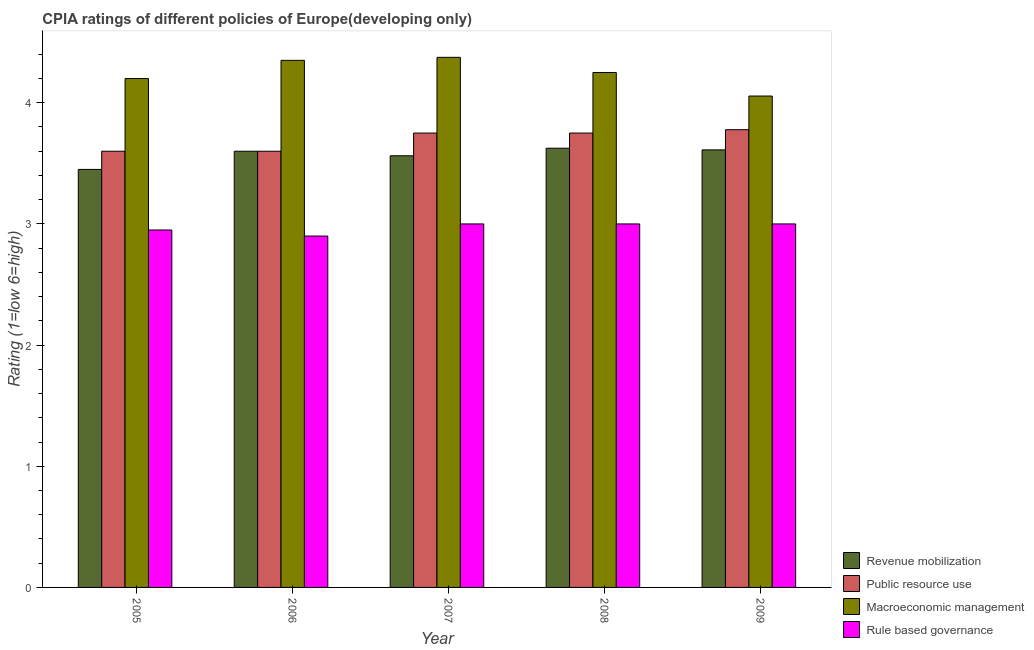How many different coloured bars are there?
Give a very brief answer. 4. Are the number of bars on each tick of the X-axis equal?
Offer a very short reply. Yes. How many bars are there on the 1st tick from the left?
Keep it short and to the point. 4. What is the cpia rating of revenue mobilization in 2008?
Provide a short and direct response. 3.62. Across all years, what is the maximum cpia rating of rule based governance?
Your response must be concise. 3. Across all years, what is the minimum cpia rating of rule based governance?
Make the answer very short. 2.9. In which year was the cpia rating of public resource use minimum?
Provide a succinct answer. 2005. What is the total cpia rating of rule based governance in the graph?
Give a very brief answer. 14.85. What is the difference between the cpia rating of macroeconomic management in 2006 and that in 2007?
Provide a short and direct response. -0.03. What is the difference between the cpia rating of public resource use in 2008 and the cpia rating of rule based governance in 2007?
Provide a short and direct response. 0. What is the average cpia rating of revenue mobilization per year?
Provide a succinct answer. 3.57. What is the ratio of the cpia rating of macroeconomic management in 2006 to that in 2007?
Your answer should be compact. 0.99. Is the difference between the cpia rating of macroeconomic management in 2005 and 2007 greater than the difference between the cpia rating of rule based governance in 2005 and 2007?
Ensure brevity in your answer.  No. What is the difference between the highest and the second highest cpia rating of macroeconomic management?
Offer a terse response. 0.03. What is the difference between the highest and the lowest cpia rating of rule based governance?
Make the answer very short. 0.1. In how many years, is the cpia rating of rule based governance greater than the average cpia rating of rule based governance taken over all years?
Offer a terse response. 3. Is it the case that in every year, the sum of the cpia rating of revenue mobilization and cpia rating of rule based governance is greater than the sum of cpia rating of public resource use and cpia rating of macroeconomic management?
Provide a succinct answer. No. What does the 1st bar from the left in 2006 represents?
Keep it short and to the point. Revenue mobilization. What does the 4th bar from the right in 2007 represents?
Your answer should be very brief. Revenue mobilization. Is it the case that in every year, the sum of the cpia rating of revenue mobilization and cpia rating of public resource use is greater than the cpia rating of macroeconomic management?
Offer a very short reply. Yes. How many bars are there?
Your response must be concise. 20. Are all the bars in the graph horizontal?
Make the answer very short. No. How many years are there in the graph?
Give a very brief answer. 5. What is the difference between two consecutive major ticks on the Y-axis?
Give a very brief answer. 1. Does the graph contain any zero values?
Your answer should be compact. No. Does the graph contain grids?
Make the answer very short. No. Where does the legend appear in the graph?
Offer a terse response. Bottom right. How are the legend labels stacked?
Offer a very short reply. Vertical. What is the title of the graph?
Your response must be concise. CPIA ratings of different policies of Europe(developing only). What is the label or title of the Y-axis?
Make the answer very short. Rating (1=low 6=high). What is the Rating (1=low 6=high) of Revenue mobilization in 2005?
Provide a short and direct response. 3.45. What is the Rating (1=low 6=high) in Public resource use in 2005?
Your answer should be compact. 3.6. What is the Rating (1=low 6=high) of Macroeconomic management in 2005?
Make the answer very short. 4.2. What is the Rating (1=low 6=high) of Rule based governance in 2005?
Your answer should be compact. 2.95. What is the Rating (1=low 6=high) in Public resource use in 2006?
Make the answer very short. 3.6. What is the Rating (1=low 6=high) of Macroeconomic management in 2006?
Give a very brief answer. 4.35. What is the Rating (1=low 6=high) in Revenue mobilization in 2007?
Provide a succinct answer. 3.56. What is the Rating (1=low 6=high) of Public resource use in 2007?
Give a very brief answer. 3.75. What is the Rating (1=low 6=high) of Macroeconomic management in 2007?
Provide a short and direct response. 4.38. What is the Rating (1=low 6=high) of Revenue mobilization in 2008?
Provide a succinct answer. 3.62. What is the Rating (1=low 6=high) in Public resource use in 2008?
Offer a very short reply. 3.75. What is the Rating (1=low 6=high) in Macroeconomic management in 2008?
Make the answer very short. 4.25. What is the Rating (1=low 6=high) in Revenue mobilization in 2009?
Your answer should be compact. 3.61. What is the Rating (1=low 6=high) of Public resource use in 2009?
Provide a succinct answer. 3.78. What is the Rating (1=low 6=high) of Macroeconomic management in 2009?
Give a very brief answer. 4.06. Across all years, what is the maximum Rating (1=low 6=high) in Revenue mobilization?
Provide a succinct answer. 3.62. Across all years, what is the maximum Rating (1=low 6=high) in Public resource use?
Ensure brevity in your answer.  3.78. Across all years, what is the maximum Rating (1=low 6=high) of Macroeconomic management?
Offer a terse response. 4.38. Across all years, what is the maximum Rating (1=low 6=high) in Rule based governance?
Ensure brevity in your answer.  3. Across all years, what is the minimum Rating (1=low 6=high) in Revenue mobilization?
Provide a short and direct response. 3.45. Across all years, what is the minimum Rating (1=low 6=high) of Public resource use?
Provide a succinct answer. 3.6. Across all years, what is the minimum Rating (1=low 6=high) in Macroeconomic management?
Your answer should be compact. 4.06. Across all years, what is the minimum Rating (1=low 6=high) in Rule based governance?
Make the answer very short. 2.9. What is the total Rating (1=low 6=high) of Revenue mobilization in the graph?
Offer a terse response. 17.85. What is the total Rating (1=low 6=high) of Public resource use in the graph?
Provide a short and direct response. 18.48. What is the total Rating (1=low 6=high) of Macroeconomic management in the graph?
Offer a terse response. 21.23. What is the total Rating (1=low 6=high) of Rule based governance in the graph?
Your answer should be compact. 14.85. What is the difference between the Rating (1=low 6=high) in Rule based governance in 2005 and that in 2006?
Offer a very short reply. 0.05. What is the difference between the Rating (1=low 6=high) in Revenue mobilization in 2005 and that in 2007?
Keep it short and to the point. -0.11. What is the difference between the Rating (1=low 6=high) in Macroeconomic management in 2005 and that in 2007?
Make the answer very short. -0.17. What is the difference between the Rating (1=low 6=high) in Rule based governance in 2005 and that in 2007?
Ensure brevity in your answer.  -0.05. What is the difference between the Rating (1=low 6=high) in Revenue mobilization in 2005 and that in 2008?
Provide a succinct answer. -0.17. What is the difference between the Rating (1=low 6=high) of Public resource use in 2005 and that in 2008?
Offer a terse response. -0.15. What is the difference between the Rating (1=low 6=high) of Macroeconomic management in 2005 and that in 2008?
Your answer should be compact. -0.05. What is the difference between the Rating (1=low 6=high) in Rule based governance in 2005 and that in 2008?
Your answer should be very brief. -0.05. What is the difference between the Rating (1=low 6=high) in Revenue mobilization in 2005 and that in 2009?
Your response must be concise. -0.16. What is the difference between the Rating (1=low 6=high) in Public resource use in 2005 and that in 2009?
Provide a succinct answer. -0.18. What is the difference between the Rating (1=low 6=high) of Macroeconomic management in 2005 and that in 2009?
Your answer should be compact. 0.14. What is the difference between the Rating (1=low 6=high) in Revenue mobilization in 2006 and that in 2007?
Provide a short and direct response. 0.04. What is the difference between the Rating (1=low 6=high) in Macroeconomic management in 2006 and that in 2007?
Keep it short and to the point. -0.03. What is the difference between the Rating (1=low 6=high) of Revenue mobilization in 2006 and that in 2008?
Offer a terse response. -0.03. What is the difference between the Rating (1=low 6=high) of Public resource use in 2006 and that in 2008?
Make the answer very short. -0.15. What is the difference between the Rating (1=low 6=high) of Macroeconomic management in 2006 and that in 2008?
Offer a terse response. 0.1. What is the difference between the Rating (1=low 6=high) in Rule based governance in 2006 and that in 2008?
Offer a terse response. -0.1. What is the difference between the Rating (1=low 6=high) of Revenue mobilization in 2006 and that in 2009?
Ensure brevity in your answer.  -0.01. What is the difference between the Rating (1=low 6=high) in Public resource use in 2006 and that in 2009?
Keep it short and to the point. -0.18. What is the difference between the Rating (1=low 6=high) of Macroeconomic management in 2006 and that in 2009?
Provide a short and direct response. 0.29. What is the difference between the Rating (1=low 6=high) in Rule based governance in 2006 and that in 2009?
Your answer should be compact. -0.1. What is the difference between the Rating (1=low 6=high) in Revenue mobilization in 2007 and that in 2008?
Make the answer very short. -0.06. What is the difference between the Rating (1=low 6=high) of Public resource use in 2007 and that in 2008?
Your answer should be very brief. 0. What is the difference between the Rating (1=low 6=high) of Rule based governance in 2007 and that in 2008?
Provide a short and direct response. 0. What is the difference between the Rating (1=low 6=high) of Revenue mobilization in 2007 and that in 2009?
Provide a short and direct response. -0.05. What is the difference between the Rating (1=low 6=high) of Public resource use in 2007 and that in 2009?
Your answer should be compact. -0.03. What is the difference between the Rating (1=low 6=high) of Macroeconomic management in 2007 and that in 2009?
Provide a succinct answer. 0.32. What is the difference between the Rating (1=low 6=high) in Rule based governance in 2007 and that in 2009?
Your answer should be very brief. 0. What is the difference between the Rating (1=low 6=high) in Revenue mobilization in 2008 and that in 2009?
Provide a succinct answer. 0.01. What is the difference between the Rating (1=low 6=high) in Public resource use in 2008 and that in 2009?
Keep it short and to the point. -0.03. What is the difference between the Rating (1=low 6=high) of Macroeconomic management in 2008 and that in 2009?
Ensure brevity in your answer.  0.19. What is the difference between the Rating (1=low 6=high) of Rule based governance in 2008 and that in 2009?
Make the answer very short. 0. What is the difference between the Rating (1=low 6=high) of Revenue mobilization in 2005 and the Rating (1=low 6=high) of Public resource use in 2006?
Keep it short and to the point. -0.15. What is the difference between the Rating (1=low 6=high) in Revenue mobilization in 2005 and the Rating (1=low 6=high) in Rule based governance in 2006?
Give a very brief answer. 0.55. What is the difference between the Rating (1=low 6=high) in Public resource use in 2005 and the Rating (1=low 6=high) in Macroeconomic management in 2006?
Provide a short and direct response. -0.75. What is the difference between the Rating (1=low 6=high) in Macroeconomic management in 2005 and the Rating (1=low 6=high) in Rule based governance in 2006?
Offer a very short reply. 1.3. What is the difference between the Rating (1=low 6=high) in Revenue mobilization in 2005 and the Rating (1=low 6=high) in Public resource use in 2007?
Your answer should be very brief. -0.3. What is the difference between the Rating (1=low 6=high) in Revenue mobilization in 2005 and the Rating (1=low 6=high) in Macroeconomic management in 2007?
Offer a very short reply. -0.93. What is the difference between the Rating (1=low 6=high) in Revenue mobilization in 2005 and the Rating (1=low 6=high) in Rule based governance in 2007?
Your response must be concise. 0.45. What is the difference between the Rating (1=low 6=high) in Public resource use in 2005 and the Rating (1=low 6=high) in Macroeconomic management in 2007?
Keep it short and to the point. -0.78. What is the difference between the Rating (1=low 6=high) in Revenue mobilization in 2005 and the Rating (1=low 6=high) in Public resource use in 2008?
Give a very brief answer. -0.3. What is the difference between the Rating (1=low 6=high) of Revenue mobilization in 2005 and the Rating (1=low 6=high) of Macroeconomic management in 2008?
Keep it short and to the point. -0.8. What is the difference between the Rating (1=low 6=high) in Revenue mobilization in 2005 and the Rating (1=low 6=high) in Rule based governance in 2008?
Offer a very short reply. 0.45. What is the difference between the Rating (1=low 6=high) of Public resource use in 2005 and the Rating (1=low 6=high) of Macroeconomic management in 2008?
Keep it short and to the point. -0.65. What is the difference between the Rating (1=low 6=high) of Revenue mobilization in 2005 and the Rating (1=low 6=high) of Public resource use in 2009?
Provide a short and direct response. -0.33. What is the difference between the Rating (1=low 6=high) in Revenue mobilization in 2005 and the Rating (1=low 6=high) in Macroeconomic management in 2009?
Offer a very short reply. -0.61. What is the difference between the Rating (1=low 6=high) of Revenue mobilization in 2005 and the Rating (1=low 6=high) of Rule based governance in 2009?
Your response must be concise. 0.45. What is the difference between the Rating (1=low 6=high) in Public resource use in 2005 and the Rating (1=low 6=high) in Macroeconomic management in 2009?
Your response must be concise. -0.46. What is the difference between the Rating (1=low 6=high) of Public resource use in 2005 and the Rating (1=low 6=high) of Rule based governance in 2009?
Provide a short and direct response. 0.6. What is the difference between the Rating (1=low 6=high) of Macroeconomic management in 2005 and the Rating (1=low 6=high) of Rule based governance in 2009?
Keep it short and to the point. 1.2. What is the difference between the Rating (1=low 6=high) in Revenue mobilization in 2006 and the Rating (1=low 6=high) in Macroeconomic management in 2007?
Provide a short and direct response. -0.78. What is the difference between the Rating (1=low 6=high) in Public resource use in 2006 and the Rating (1=low 6=high) in Macroeconomic management in 2007?
Provide a succinct answer. -0.78. What is the difference between the Rating (1=low 6=high) in Public resource use in 2006 and the Rating (1=low 6=high) in Rule based governance in 2007?
Offer a terse response. 0.6. What is the difference between the Rating (1=low 6=high) in Macroeconomic management in 2006 and the Rating (1=low 6=high) in Rule based governance in 2007?
Provide a succinct answer. 1.35. What is the difference between the Rating (1=low 6=high) of Revenue mobilization in 2006 and the Rating (1=low 6=high) of Macroeconomic management in 2008?
Keep it short and to the point. -0.65. What is the difference between the Rating (1=low 6=high) in Public resource use in 2006 and the Rating (1=low 6=high) in Macroeconomic management in 2008?
Make the answer very short. -0.65. What is the difference between the Rating (1=low 6=high) of Public resource use in 2006 and the Rating (1=low 6=high) of Rule based governance in 2008?
Provide a short and direct response. 0.6. What is the difference between the Rating (1=low 6=high) in Macroeconomic management in 2006 and the Rating (1=low 6=high) in Rule based governance in 2008?
Keep it short and to the point. 1.35. What is the difference between the Rating (1=low 6=high) in Revenue mobilization in 2006 and the Rating (1=low 6=high) in Public resource use in 2009?
Offer a very short reply. -0.18. What is the difference between the Rating (1=low 6=high) of Revenue mobilization in 2006 and the Rating (1=low 6=high) of Macroeconomic management in 2009?
Offer a terse response. -0.46. What is the difference between the Rating (1=low 6=high) in Revenue mobilization in 2006 and the Rating (1=low 6=high) in Rule based governance in 2009?
Your answer should be very brief. 0.6. What is the difference between the Rating (1=low 6=high) in Public resource use in 2006 and the Rating (1=low 6=high) in Macroeconomic management in 2009?
Your answer should be very brief. -0.46. What is the difference between the Rating (1=low 6=high) of Macroeconomic management in 2006 and the Rating (1=low 6=high) of Rule based governance in 2009?
Make the answer very short. 1.35. What is the difference between the Rating (1=low 6=high) of Revenue mobilization in 2007 and the Rating (1=low 6=high) of Public resource use in 2008?
Offer a very short reply. -0.19. What is the difference between the Rating (1=low 6=high) in Revenue mobilization in 2007 and the Rating (1=low 6=high) in Macroeconomic management in 2008?
Your response must be concise. -0.69. What is the difference between the Rating (1=low 6=high) in Revenue mobilization in 2007 and the Rating (1=low 6=high) in Rule based governance in 2008?
Give a very brief answer. 0.56. What is the difference between the Rating (1=low 6=high) of Macroeconomic management in 2007 and the Rating (1=low 6=high) of Rule based governance in 2008?
Your response must be concise. 1.38. What is the difference between the Rating (1=low 6=high) of Revenue mobilization in 2007 and the Rating (1=low 6=high) of Public resource use in 2009?
Your response must be concise. -0.22. What is the difference between the Rating (1=low 6=high) in Revenue mobilization in 2007 and the Rating (1=low 6=high) in Macroeconomic management in 2009?
Provide a succinct answer. -0.49. What is the difference between the Rating (1=low 6=high) of Revenue mobilization in 2007 and the Rating (1=low 6=high) of Rule based governance in 2009?
Give a very brief answer. 0.56. What is the difference between the Rating (1=low 6=high) of Public resource use in 2007 and the Rating (1=low 6=high) of Macroeconomic management in 2009?
Offer a very short reply. -0.31. What is the difference between the Rating (1=low 6=high) in Public resource use in 2007 and the Rating (1=low 6=high) in Rule based governance in 2009?
Your answer should be compact. 0.75. What is the difference between the Rating (1=low 6=high) in Macroeconomic management in 2007 and the Rating (1=low 6=high) in Rule based governance in 2009?
Your answer should be compact. 1.38. What is the difference between the Rating (1=low 6=high) of Revenue mobilization in 2008 and the Rating (1=low 6=high) of Public resource use in 2009?
Keep it short and to the point. -0.15. What is the difference between the Rating (1=low 6=high) of Revenue mobilization in 2008 and the Rating (1=low 6=high) of Macroeconomic management in 2009?
Your answer should be compact. -0.43. What is the difference between the Rating (1=low 6=high) in Revenue mobilization in 2008 and the Rating (1=low 6=high) in Rule based governance in 2009?
Your response must be concise. 0.62. What is the difference between the Rating (1=low 6=high) of Public resource use in 2008 and the Rating (1=low 6=high) of Macroeconomic management in 2009?
Offer a terse response. -0.31. What is the average Rating (1=low 6=high) of Revenue mobilization per year?
Your answer should be compact. 3.57. What is the average Rating (1=low 6=high) of Public resource use per year?
Offer a very short reply. 3.7. What is the average Rating (1=low 6=high) of Macroeconomic management per year?
Provide a short and direct response. 4.25. What is the average Rating (1=low 6=high) of Rule based governance per year?
Keep it short and to the point. 2.97. In the year 2005, what is the difference between the Rating (1=low 6=high) in Revenue mobilization and Rating (1=low 6=high) in Public resource use?
Make the answer very short. -0.15. In the year 2005, what is the difference between the Rating (1=low 6=high) in Revenue mobilization and Rating (1=low 6=high) in Macroeconomic management?
Keep it short and to the point. -0.75. In the year 2005, what is the difference between the Rating (1=low 6=high) in Revenue mobilization and Rating (1=low 6=high) in Rule based governance?
Keep it short and to the point. 0.5. In the year 2005, what is the difference between the Rating (1=low 6=high) of Public resource use and Rating (1=low 6=high) of Macroeconomic management?
Offer a very short reply. -0.6. In the year 2005, what is the difference between the Rating (1=low 6=high) in Public resource use and Rating (1=low 6=high) in Rule based governance?
Ensure brevity in your answer.  0.65. In the year 2006, what is the difference between the Rating (1=low 6=high) in Revenue mobilization and Rating (1=low 6=high) in Public resource use?
Provide a succinct answer. 0. In the year 2006, what is the difference between the Rating (1=low 6=high) of Revenue mobilization and Rating (1=low 6=high) of Macroeconomic management?
Your response must be concise. -0.75. In the year 2006, what is the difference between the Rating (1=low 6=high) of Revenue mobilization and Rating (1=low 6=high) of Rule based governance?
Offer a very short reply. 0.7. In the year 2006, what is the difference between the Rating (1=low 6=high) in Public resource use and Rating (1=low 6=high) in Macroeconomic management?
Offer a terse response. -0.75. In the year 2006, what is the difference between the Rating (1=low 6=high) of Public resource use and Rating (1=low 6=high) of Rule based governance?
Offer a terse response. 0.7. In the year 2006, what is the difference between the Rating (1=low 6=high) in Macroeconomic management and Rating (1=low 6=high) in Rule based governance?
Make the answer very short. 1.45. In the year 2007, what is the difference between the Rating (1=low 6=high) in Revenue mobilization and Rating (1=low 6=high) in Public resource use?
Keep it short and to the point. -0.19. In the year 2007, what is the difference between the Rating (1=low 6=high) of Revenue mobilization and Rating (1=low 6=high) of Macroeconomic management?
Provide a succinct answer. -0.81. In the year 2007, what is the difference between the Rating (1=low 6=high) in Revenue mobilization and Rating (1=low 6=high) in Rule based governance?
Ensure brevity in your answer.  0.56. In the year 2007, what is the difference between the Rating (1=low 6=high) in Public resource use and Rating (1=low 6=high) in Macroeconomic management?
Keep it short and to the point. -0.62. In the year 2007, what is the difference between the Rating (1=low 6=high) of Macroeconomic management and Rating (1=low 6=high) of Rule based governance?
Give a very brief answer. 1.38. In the year 2008, what is the difference between the Rating (1=low 6=high) of Revenue mobilization and Rating (1=low 6=high) of Public resource use?
Your answer should be compact. -0.12. In the year 2008, what is the difference between the Rating (1=low 6=high) in Revenue mobilization and Rating (1=low 6=high) in Macroeconomic management?
Offer a terse response. -0.62. In the year 2008, what is the difference between the Rating (1=low 6=high) of Public resource use and Rating (1=low 6=high) of Macroeconomic management?
Make the answer very short. -0.5. In the year 2009, what is the difference between the Rating (1=low 6=high) of Revenue mobilization and Rating (1=low 6=high) of Public resource use?
Offer a very short reply. -0.17. In the year 2009, what is the difference between the Rating (1=low 6=high) in Revenue mobilization and Rating (1=low 6=high) in Macroeconomic management?
Your answer should be compact. -0.44. In the year 2009, what is the difference between the Rating (1=low 6=high) in Revenue mobilization and Rating (1=low 6=high) in Rule based governance?
Give a very brief answer. 0.61. In the year 2009, what is the difference between the Rating (1=low 6=high) in Public resource use and Rating (1=low 6=high) in Macroeconomic management?
Offer a terse response. -0.28. In the year 2009, what is the difference between the Rating (1=low 6=high) of Macroeconomic management and Rating (1=low 6=high) of Rule based governance?
Give a very brief answer. 1.06. What is the ratio of the Rating (1=low 6=high) of Revenue mobilization in 2005 to that in 2006?
Keep it short and to the point. 0.96. What is the ratio of the Rating (1=low 6=high) in Macroeconomic management in 2005 to that in 2006?
Ensure brevity in your answer.  0.97. What is the ratio of the Rating (1=low 6=high) in Rule based governance in 2005 to that in 2006?
Keep it short and to the point. 1.02. What is the ratio of the Rating (1=low 6=high) in Revenue mobilization in 2005 to that in 2007?
Your answer should be very brief. 0.97. What is the ratio of the Rating (1=low 6=high) in Macroeconomic management in 2005 to that in 2007?
Your answer should be very brief. 0.96. What is the ratio of the Rating (1=low 6=high) in Rule based governance in 2005 to that in 2007?
Your response must be concise. 0.98. What is the ratio of the Rating (1=low 6=high) of Revenue mobilization in 2005 to that in 2008?
Ensure brevity in your answer.  0.95. What is the ratio of the Rating (1=low 6=high) of Public resource use in 2005 to that in 2008?
Keep it short and to the point. 0.96. What is the ratio of the Rating (1=low 6=high) of Rule based governance in 2005 to that in 2008?
Offer a very short reply. 0.98. What is the ratio of the Rating (1=low 6=high) of Revenue mobilization in 2005 to that in 2009?
Give a very brief answer. 0.96. What is the ratio of the Rating (1=low 6=high) in Public resource use in 2005 to that in 2009?
Ensure brevity in your answer.  0.95. What is the ratio of the Rating (1=low 6=high) in Macroeconomic management in 2005 to that in 2009?
Ensure brevity in your answer.  1.04. What is the ratio of the Rating (1=low 6=high) in Rule based governance in 2005 to that in 2009?
Your response must be concise. 0.98. What is the ratio of the Rating (1=low 6=high) in Revenue mobilization in 2006 to that in 2007?
Give a very brief answer. 1.01. What is the ratio of the Rating (1=low 6=high) of Rule based governance in 2006 to that in 2007?
Ensure brevity in your answer.  0.97. What is the ratio of the Rating (1=low 6=high) of Public resource use in 2006 to that in 2008?
Ensure brevity in your answer.  0.96. What is the ratio of the Rating (1=low 6=high) in Macroeconomic management in 2006 to that in 2008?
Provide a succinct answer. 1.02. What is the ratio of the Rating (1=low 6=high) of Rule based governance in 2006 to that in 2008?
Keep it short and to the point. 0.97. What is the ratio of the Rating (1=low 6=high) in Revenue mobilization in 2006 to that in 2009?
Your answer should be compact. 1. What is the ratio of the Rating (1=low 6=high) in Public resource use in 2006 to that in 2009?
Give a very brief answer. 0.95. What is the ratio of the Rating (1=low 6=high) in Macroeconomic management in 2006 to that in 2009?
Your response must be concise. 1.07. What is the ratio of the Rating (1=low 6=high) in Rule based governance in 2006 to that in 2009?
Give a very brief answer. 0.97. What is the ratio of the Rating (1=low 6=high) of Revenue mobilization in 2007 to that in 2008?
Make the answer very short. 0.98. What is the ratio of the Rating (1=low 6=high) of Macroeconomic management in 2007 to that in 2008?
Offer a terse response. 1.03. What is the ratio of the Rating (1=low 6=high) of Rule based governance in 2007 to that in 2008?
Give a very brief answer. 1. What is the ratio of the Rating (1=low 6=high) in Revenue mobilization in 2007 to that in 2009?
Make the answer very short. 0.99. What is the ratio of the Rating (1=low 6=high) of Public resource use in 2007 to that in 2009?
Give a very brief answer. 0.99. What is the ratio of the Rating (1=low 6=high) in Macroeconomic management in 2007 to that in 2009?
Your answer should be very brief. 1.08. What is the ratio of the Rating (1=low 6=high) in Revenue mobilization in 2008 to that in 2009?
Give a very brief answer. 1. What is the ratio of the Rating (1=low 6=high) of Macroeconomic management in 2008 to that in 2009?
Provide a succinct answer. 1.05. What is the difference between the highest and the second highest Rating (1=low 6=high) in Revenue mobilization?
Provide a short and direct response. 0.01. What is the difference between the highest and the second highest Rating (1=low 6=high) of Public resource use?
Your answer should be compact. 0.03. What is the difference between the highest and the second highest Rating (1=low 6=high) of Macroeconomic management?
Provide a short and direct response. 0.03. What is the difference between the highest and the second highest Rating (1=low 6=high) of Rule based governance?
Offer a very short reply. 0. What is the difference between the highest and the lowest Rating (1=low 6=high) of Revenue mobilization?
Your answer should be compact. 0.17. What is the difference between the highest and the lowest Rating (1=low 6=high) of Public resource use?
Provide a succinct answer. 0.18. What is the difference between the highest and the lowest Rating (1=low 6=high) in Macroeconomic management?
Keep it short and to the point. 0.32. 